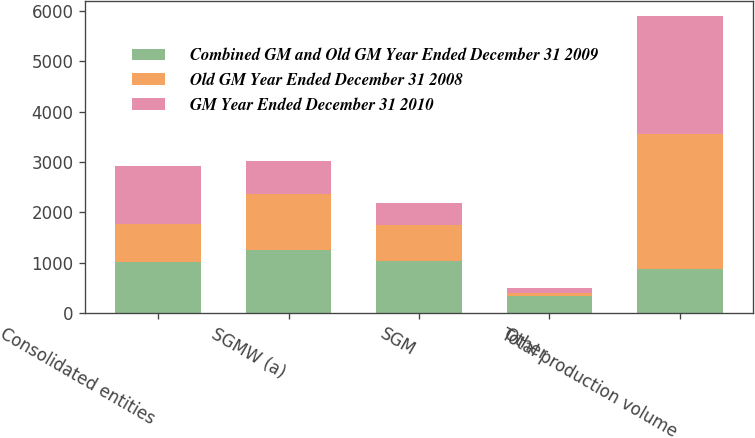<chart> <loc_0><loc_0><loc_500><loc_500><stacked_bar_chart><ecel><fcel>Consolidated entities<fcel>SGMW (a)<fcel>SGM<fcel>Other<fcel>Total production volume<nl><fcel>Combined GM and Old GM Year Ended December 31 2009<fcel>1016<fcel>1256<fcel>1037<fcel>350<fcel>884<nl><fcel>Old GM Year Ended December 31 2008<fcel>752<fcel>1109<fcel>712<fcel>61<fcel>2677<nl><fcel>GM Year Ended December 31 2010<fcel>1153<fcel>646<fcel>439<fcel>97<fcel>2335<nl></chart> 